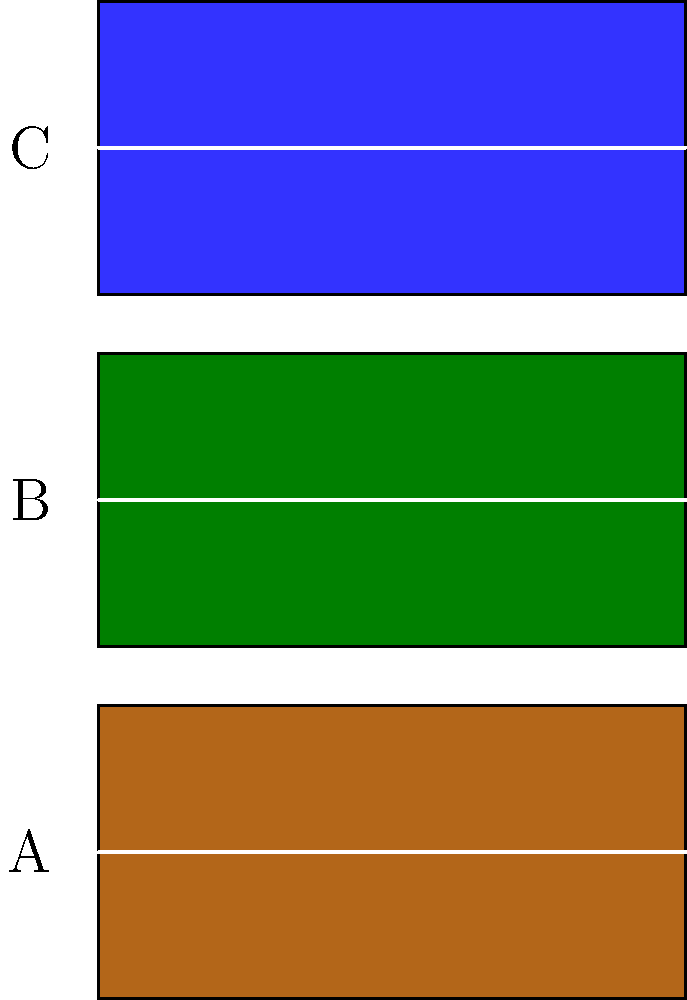As a tennis player familiar with various court surfaces, which of the courts A, B, and C in the satellite imagery above represents a clay court? To identify the clay court from the satellite imagery, let's analyze each court:

1. Court A (bottom):
   - Color: Reddish-brown
   - This color is characteristic of clay courts, which are typically made from crushed brick, shale, or stone.

2. Court B (middle):
   - Color: Green
   - This color suggests a grass court, which is less common but still used in some tournaments, most notably Wimbledon.

3. Court C (top):
   - Color: Blue
   - This color indicates a hard court, which is often made of acrylic over asphalt or concrete. Blue hard courts have become increasingly popular in recent years.

Clay courts are known for their distinctive reddish-brown color, which comes from the crushed brick or stone used in their construction. This color is clearly visible in Court A.

Clay courts have unique properties that affect gameplay:
- Slower ball speed
- Higher bounce
- Players can slide on the surface

These characteristics make clay courts favored by baseline players and those who use a lot of spin in their shots.

Given your experience as an avid tennis player who enjoys regular matches, you would likely be familiar with the appearance and characteristics of different court surfaces, making it easier to identify the clay court in this satellite imagery.
Answer: A 